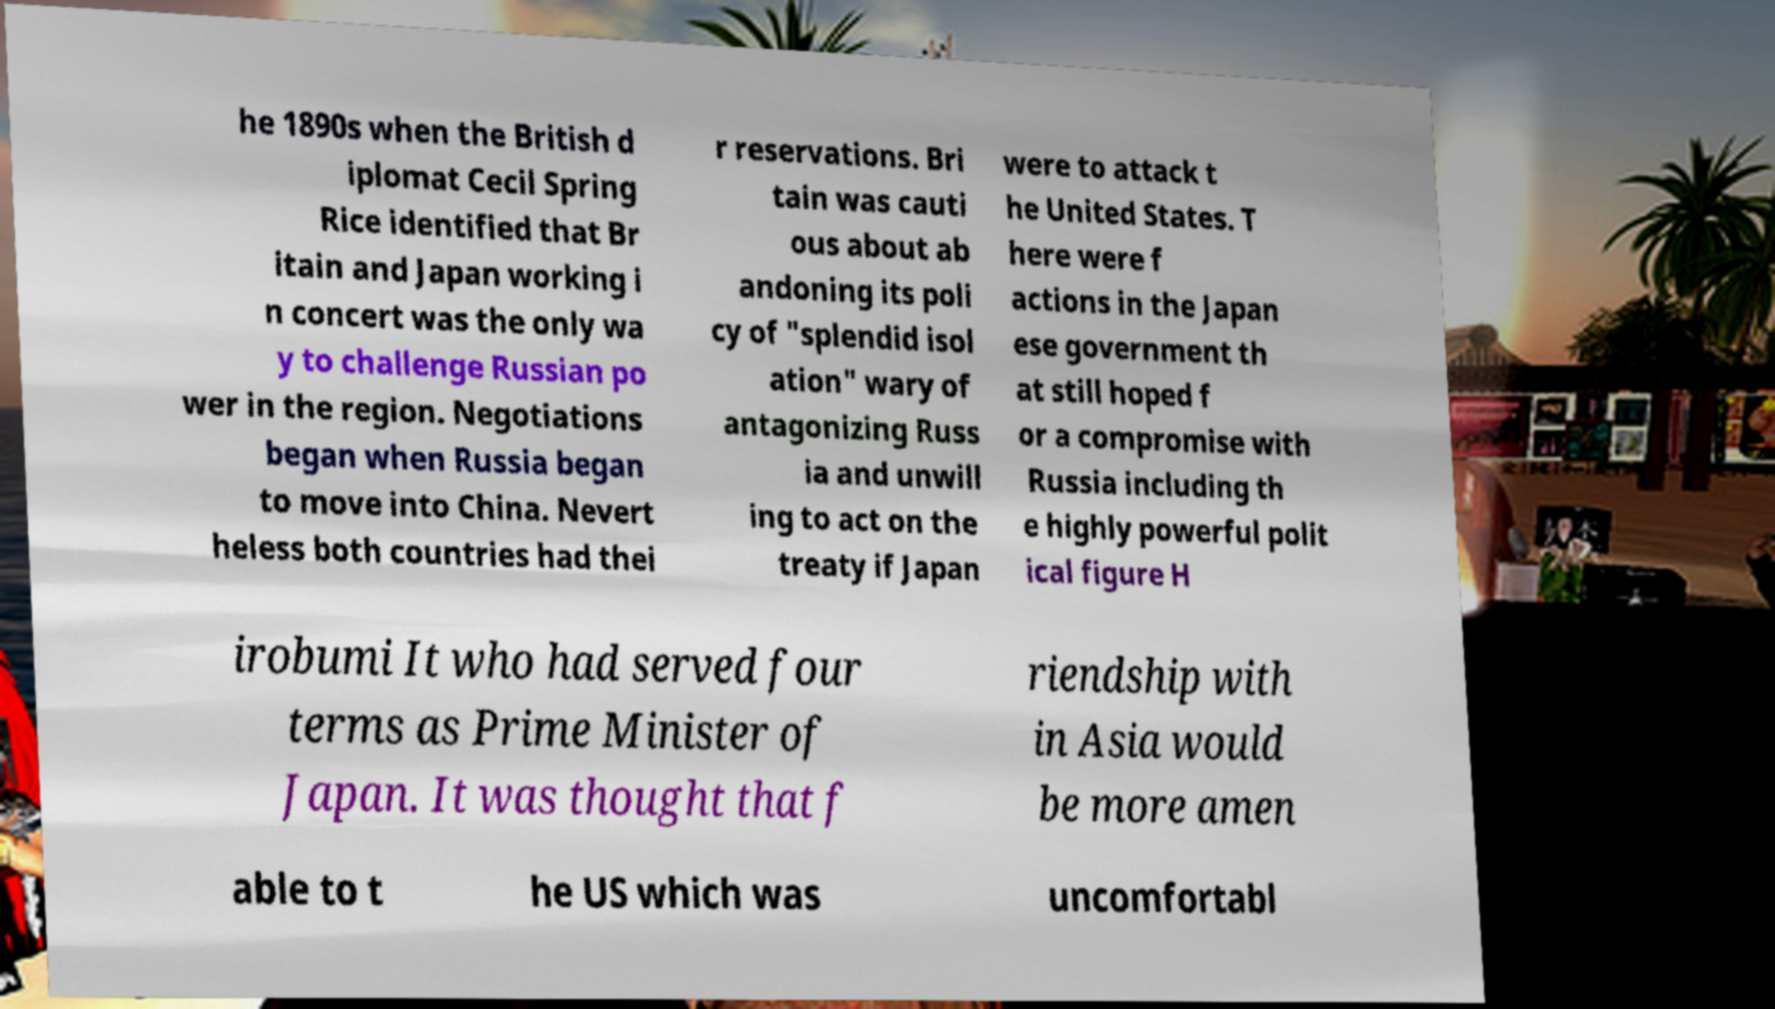For documentation purposes, I need the text within this image transcribed. Could you provide that? he 1890s when the British d iplomat Cecil Spring Rice identified that Br itain and Japan working i n concert was the only wa y to challenge Russian po wer in the region. Negotiations began when Russia began to move into China. Nevert heless both countries had thei r reservations. Bri tain was cauti ous about ab andoning its poli cy of "splendid isol ation" wary of antagonizing Russ ia and unwill ing to act on the treaty if Japan were to attack t he United States. T here were f actions in the Japan ese government th at still hoped f or a compromise with Russia including th e highly powerful polit ical figure H irobumi It who had served four terms as Prime Minister of Japan. It was thought that f riendship with in Asia would be more amen able to t he US which was uncomfortabl 